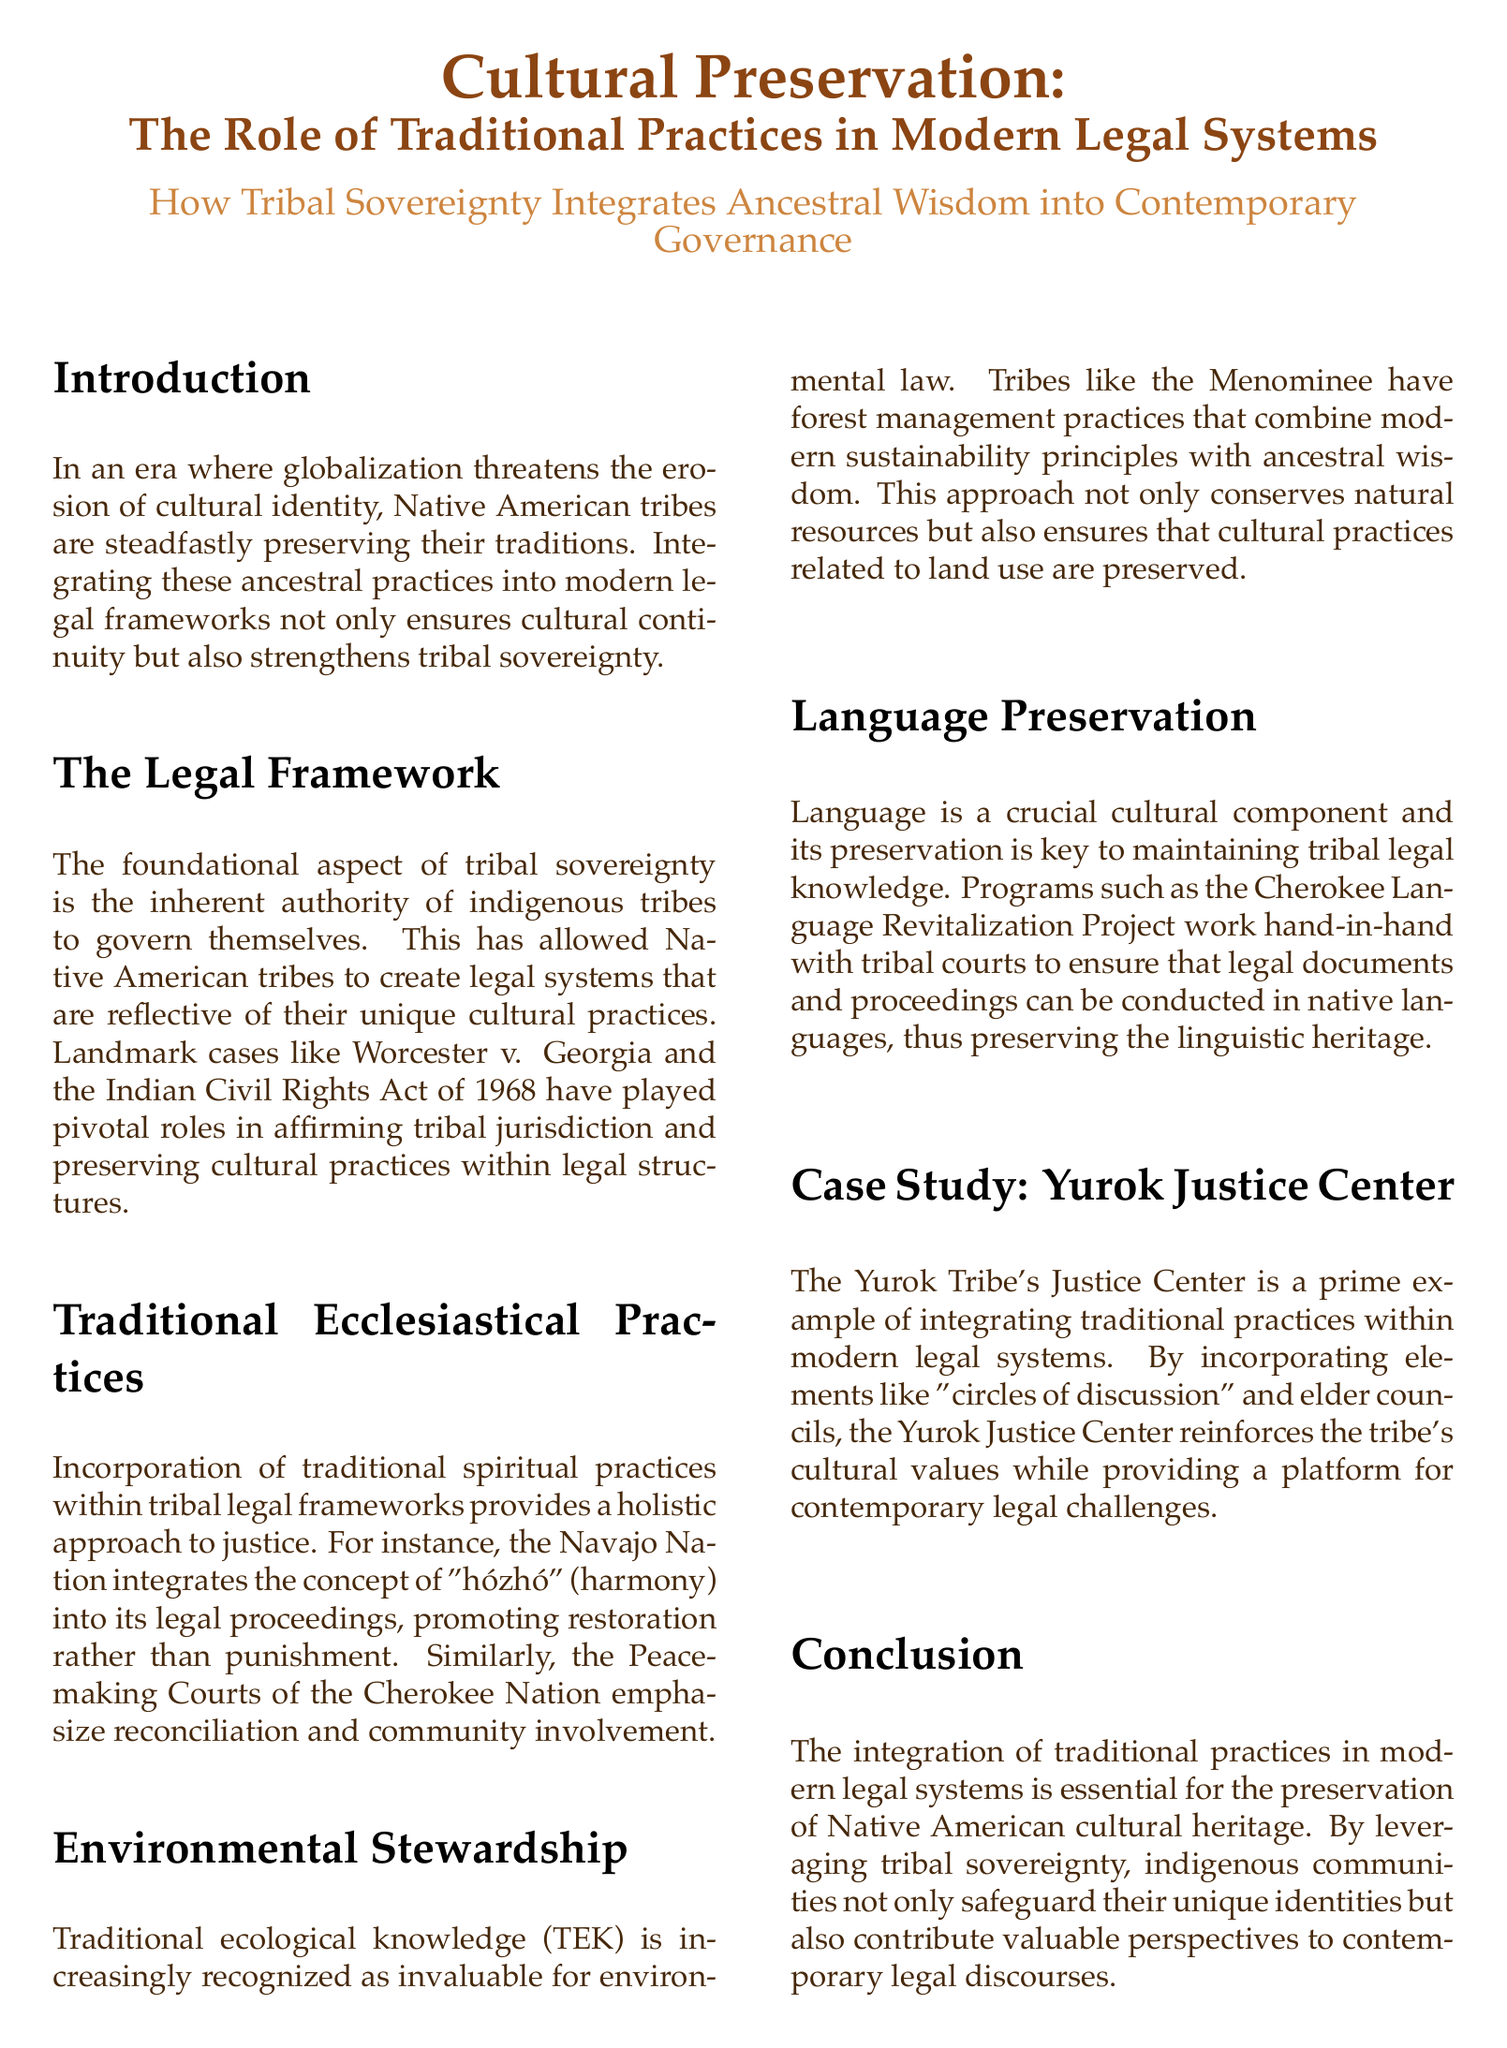What is the title of the document? The title of the document is prominently displayed at the top and reads "Cultural Preservation: The Role of Traditional Practices in Modern Legal Systems."
Answer: Cultural Preservation: The Role of Traditional Practices in Modern Legal Systems What landmark case affirmed tribal jurisdiction? The document mentions Worcester v. Georgia, which is a significant case regarding tribal sovereignty.
Answer: Worcester v. Georgia What is emphasized in the Peacemaking Courts of the Cherokee Nation? The document states that Peacemaking Courts emphasize reconciliation and community involvement as part of their legal approach.
Answer: Reconciliation What ecological knowledge does the Menominee tribe utilize? Traditional ecological knowledge (TEK) is identified as an invaluable resource for environmental law by the Menominee tribe.
Answer: Traditional ecological knowledge (TEK) Which language revitalization project is mentioned? The document references the Cherokee Language Revitalization Project in the context of language preservation.
Answer: Cherokee Language Revitalization Project What holistic approach does the Navajo Nation integrate into its legal proceedings? The Navajo Nation incorporates the concept of "hózhó," which focuses on harmony within their legal processes.
Answer: hózhó What type of justice does the Yurok Tribe's Justice Center implement? The Yurok Tribe's Justice Center implements elements like "circles of discussion" as part of their approach to justice.
Answer: circles of discussion How does tribal sovereignty contribute to cultural preservation? The conclusion of the document states that leveraging tribal sovereignty helps safeguard unique identities and provides valuable legal perspectives.
Answer: Helps safeguard unique identities What role do elder councils play in the Yurok Tribe's Justice Center? Elder councils are mentioned as part of integrating traditional practices within the modern legal system at the Yurok Justice Center.
Answer: Integrating traditional practices 